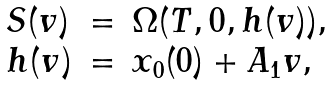<formula> <loc_0><loc_0><loc_500><loc_500>\begin{array} { l l l } S ( v ) & = & \Omega ( T , 0 , h ( v ) ) , \\ h ( v ) & = & { x } _ { 0 } ( 0 ) + A _ { 1 } v , \end{array}</formula> 